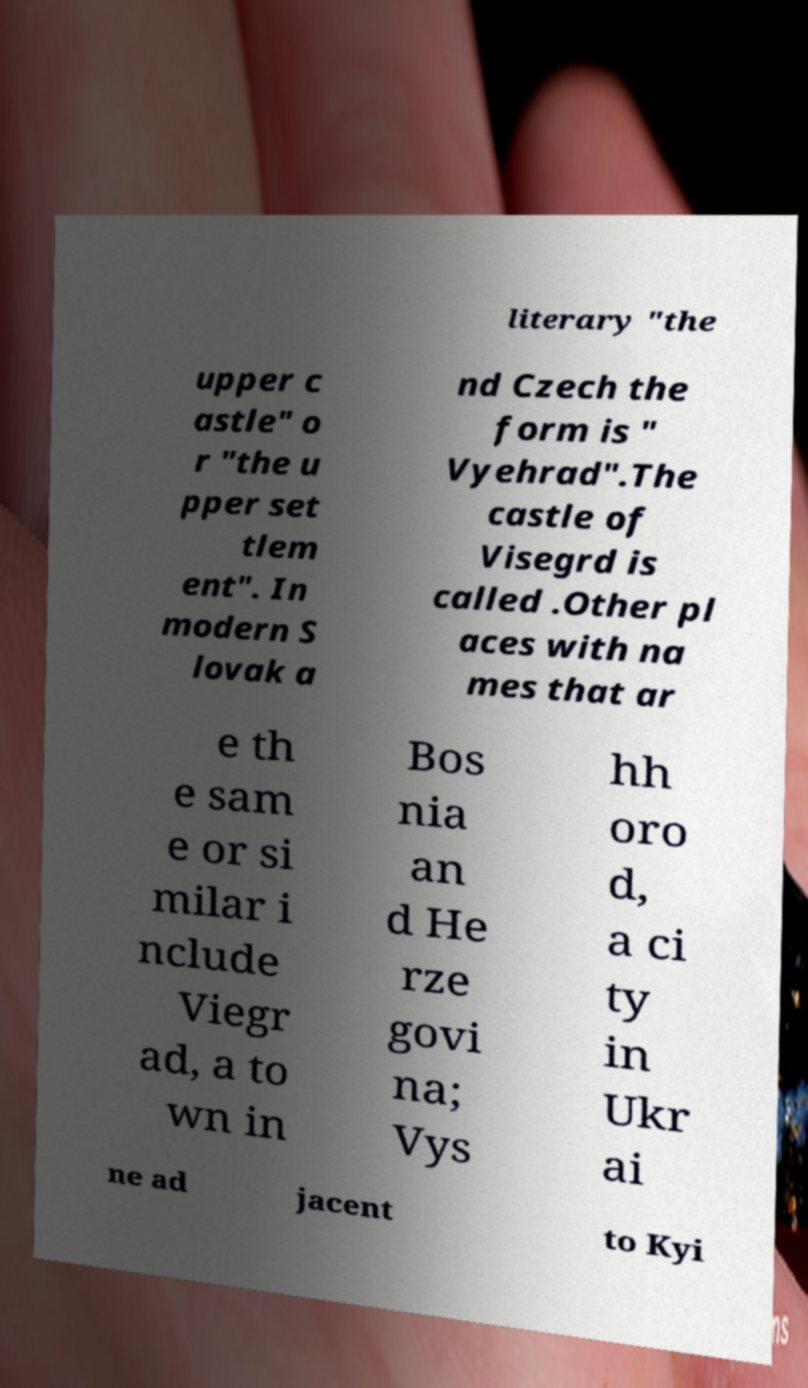Please identify and transcribe the text found in this image. literary "the upper c astle" o r "the u pper set tlem ent". In modern S lovak a nd Czech the form is " Vyehrad".The castle of Visegrd is called .Other pl aces with na mes that ar e th e sam e or si milar i nclude Viegr ad, a to wn in Bos nia an d He rze govi na; Vys hh oro d, a ci ty in Ukr ai ne ad jacent to Kyi 